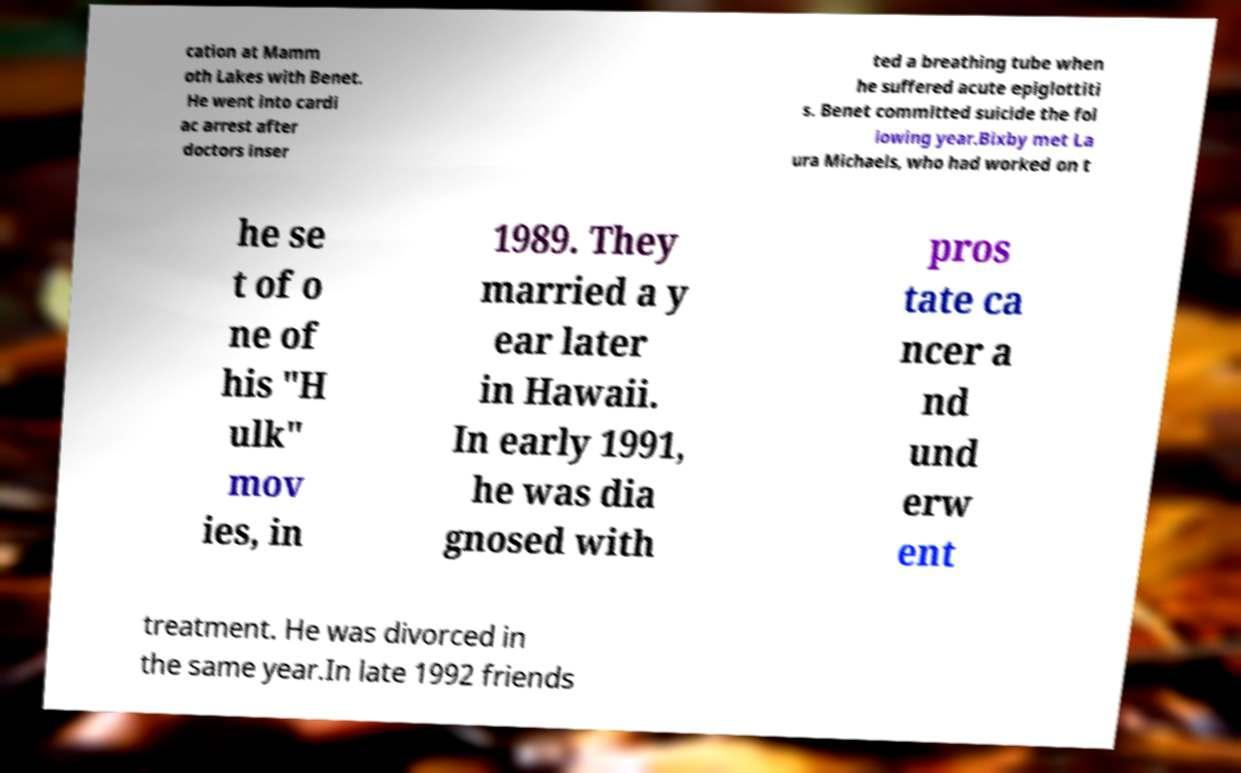Please identify and transcribe the text found in this image. cation at Mamm oth Lakes with Benet. He went into cardi ac arrest after doctors inser ted a breathing tube when he suffered acute epiglottiti s. Benet committed suicide the fol lowing year.Bixby met La ura Michaels, who had worked on t he se t of o ne of his "H ulk" mov ies, in 1989. They married a y ear later in Hawaii. In early 1991, he was dia gnosed with pros tate ca ncer a nd und erw ent treatment. He was divorced in the same year.In late 1992 friends 